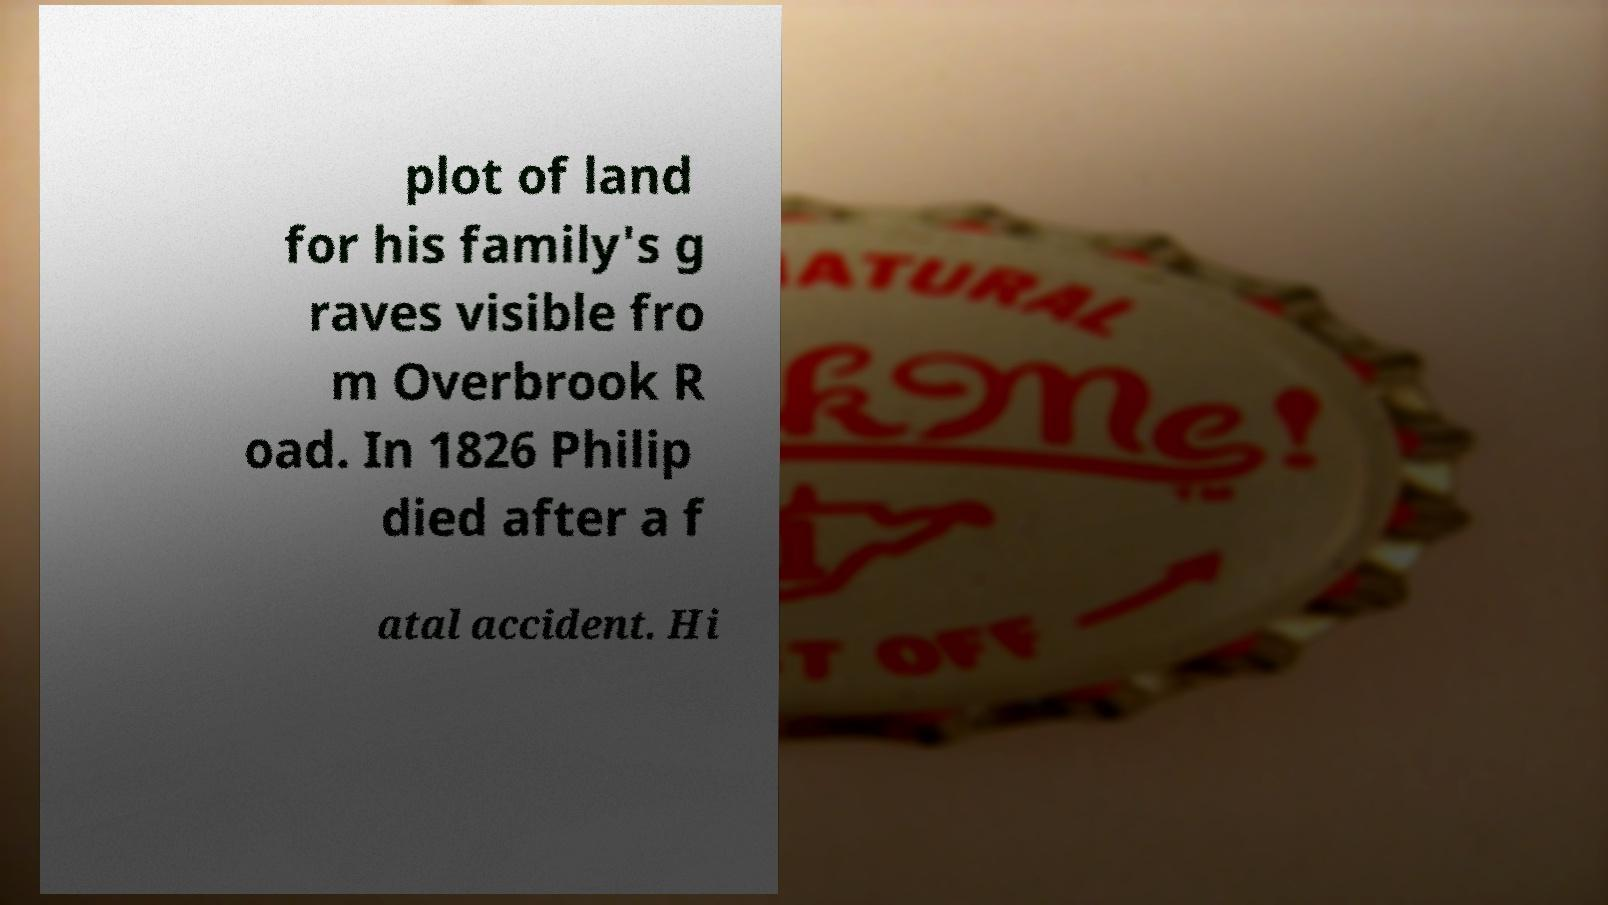Could you extract and type out the text from this image? plot of land for his family's g raves visible fro m Overbrook R oad. In 1826 Philip died after a f atal accident. Hi 